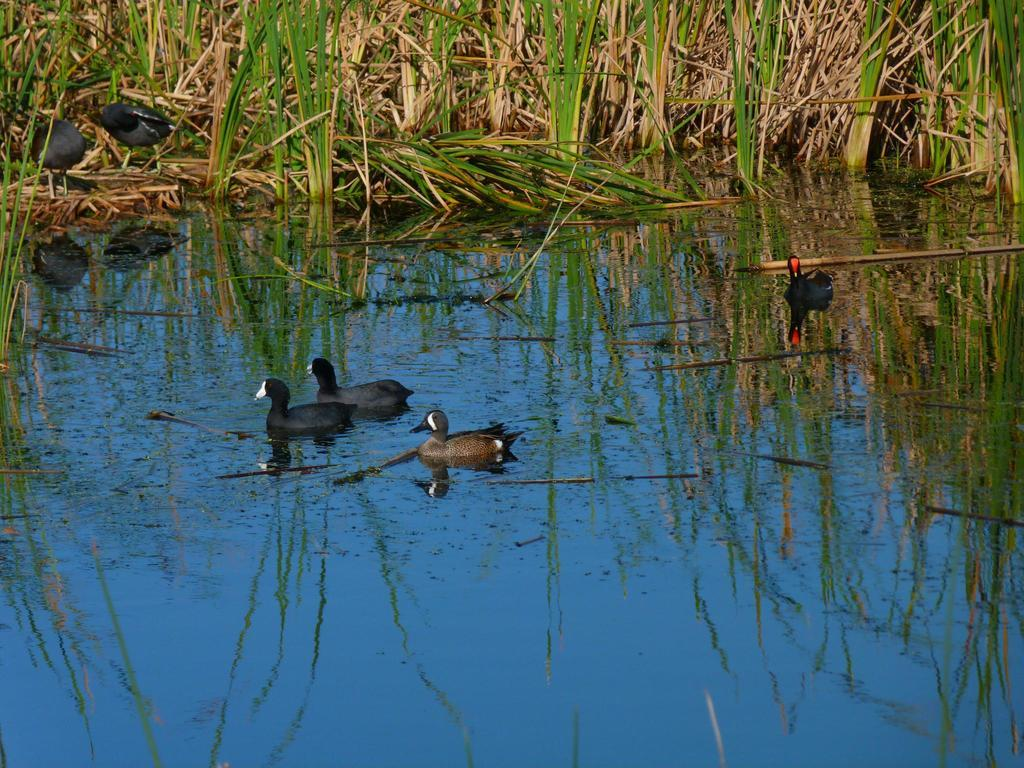What type of animals can be seen in the image? Birds can be seen in the image. What is the primary element in which the birds are situated? The birds are situated in water. What type of vegetation is visible in the image? There is grass in the image. What color is the silver slip in the image? There is no silver slip present in the image. 